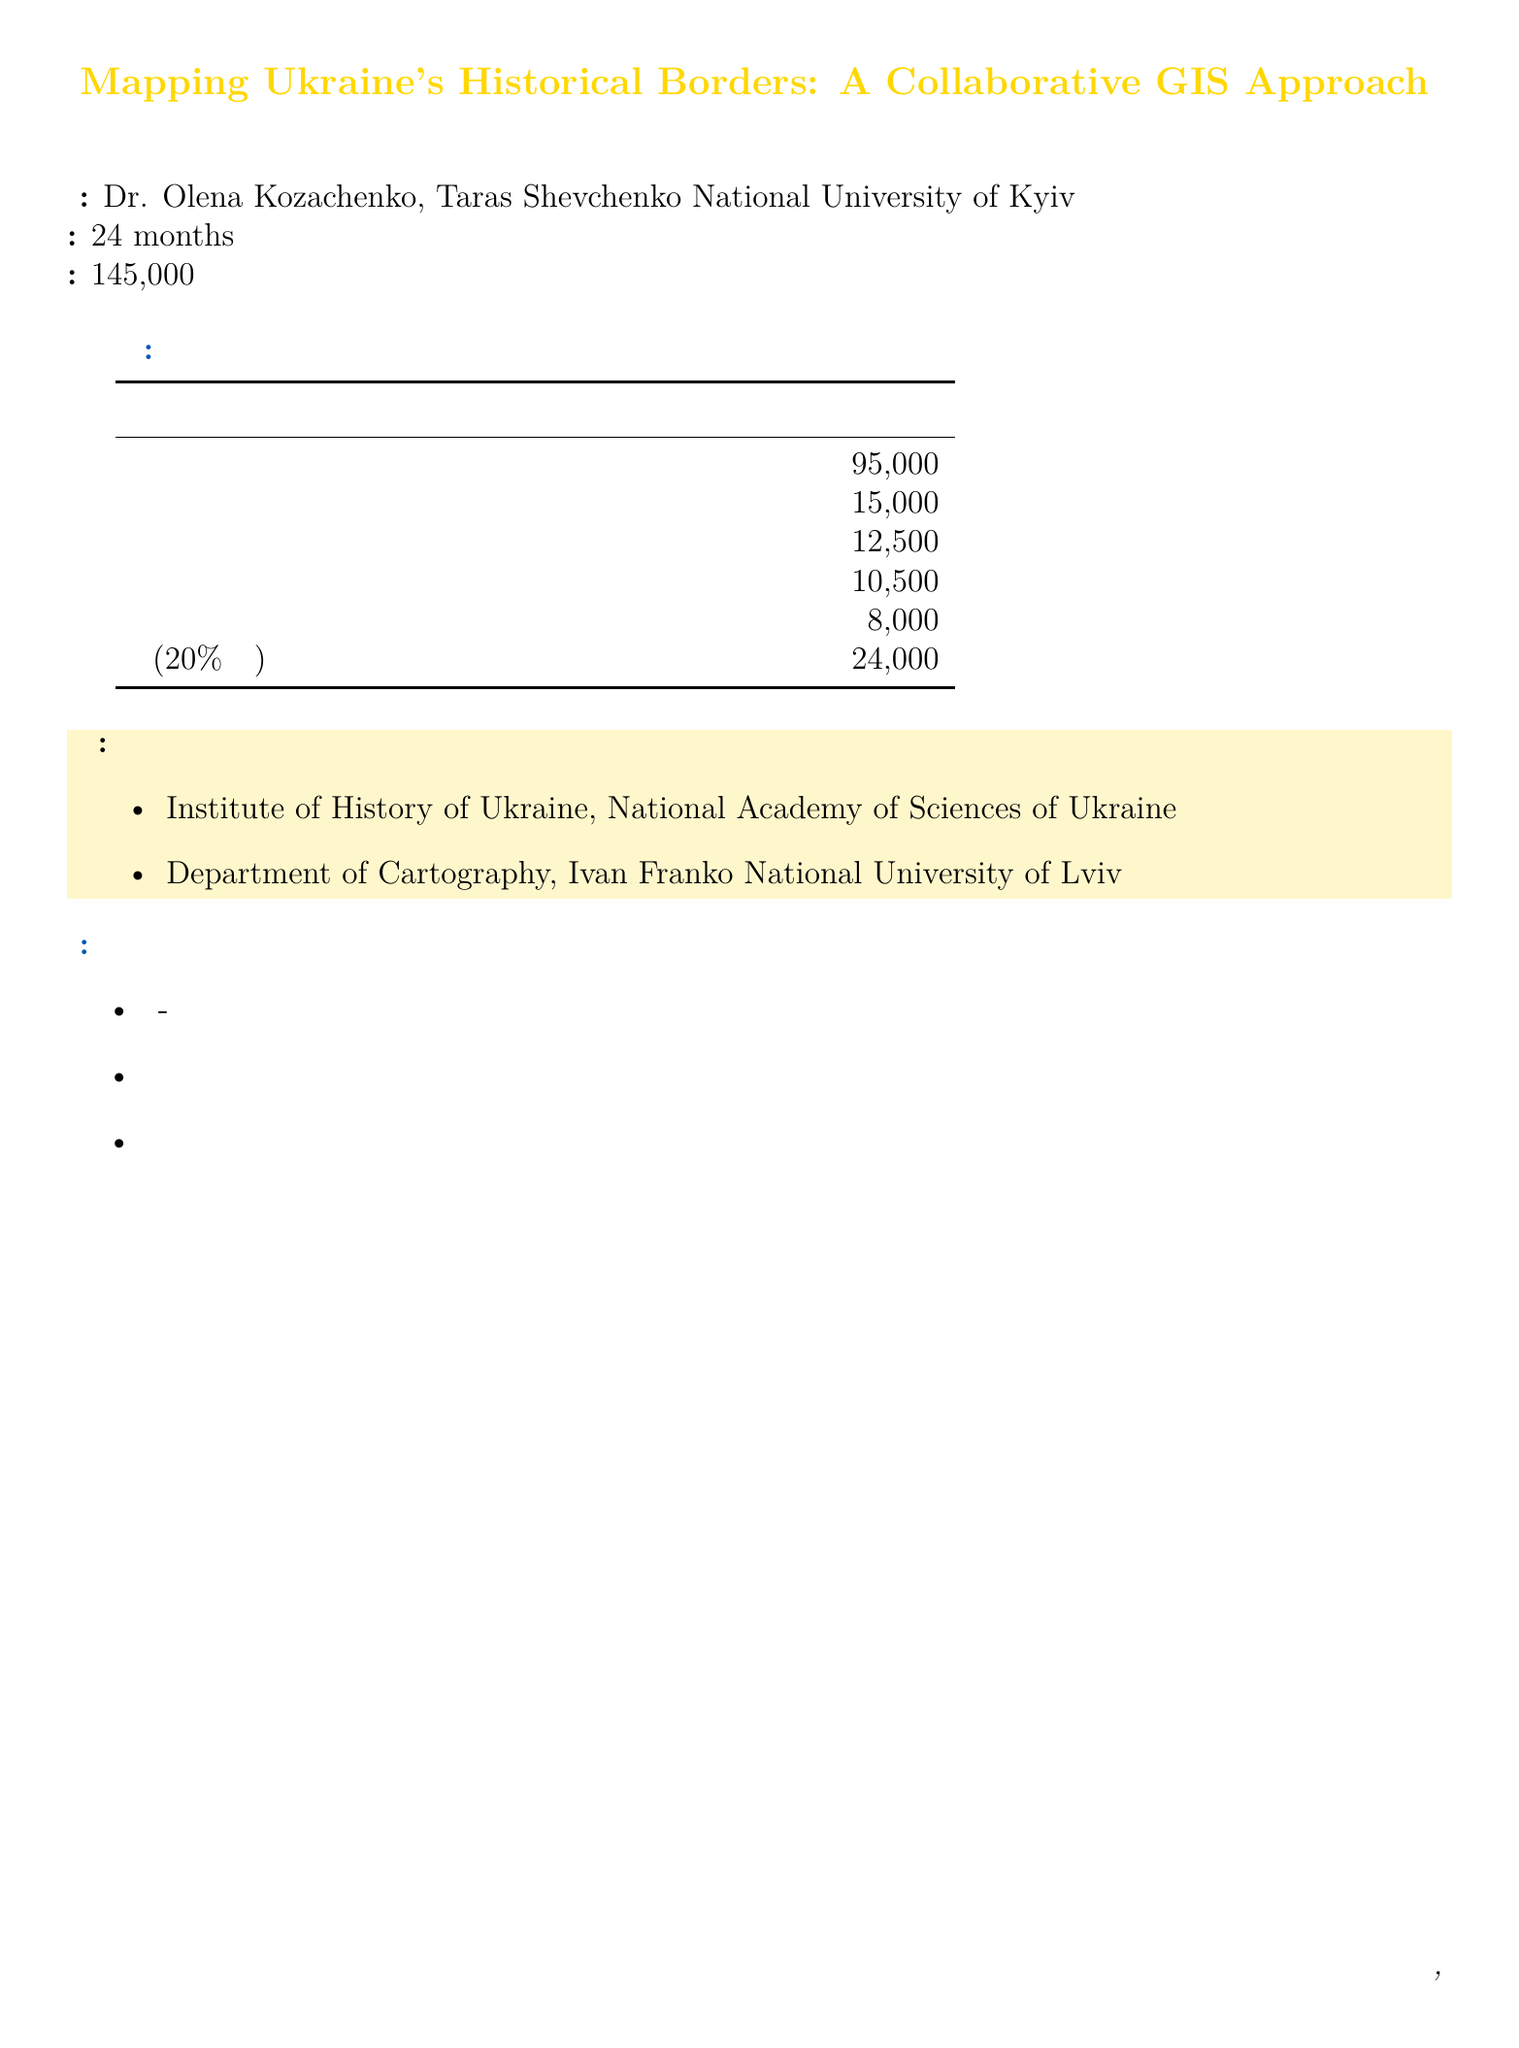What is the project title? The project title is stated at the beginning of the document.
Answer: Mapping Ukraine's Historical Borders: A Collaborative GIS Approach Who is the principal investigator? The principal investigator's name is provided in the document.
Answer: Dr. Olena Kozachenko What is the total budget for the project? The total budget is explicitly mentioned in the document.
Answer: €145,000 How many high-performance workstations are budgeted? The document specifies the number of high-performance workstations included in the budget.
Answer: 3 What percentage of direct costs are allocated for indirect costs? The document indicates the method of calculating indirect costs.
Answer: 20% What is the cost for historical maps from the Vernadsky National Library of Ukraine? This itemized cost is listed in the data acquisition section of the budget breakdown.
Answer: €5,000 What are the expected outcomes of the project? The expected outcomes are clearly listed in the document.
Answer: Interactive web-based map of Ukraine's historical borders from Kievan Rus to present day Which institution is collaborating on this project? The document lists collaborating institutions at the bottom.
Answer: Institute of History of Ukraine, National Academy of Sciences of Ukraine How much is allocated for conference attendance? The budget breakdown provides the specific amount set aside for conference costs.
Answer: €6,000 